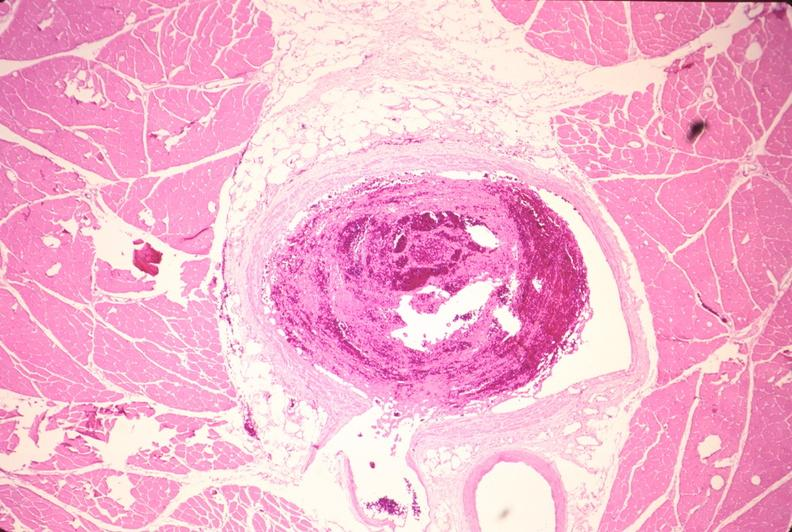s cardiovascular present?
Answer the question using a single word or phrase. Yes 